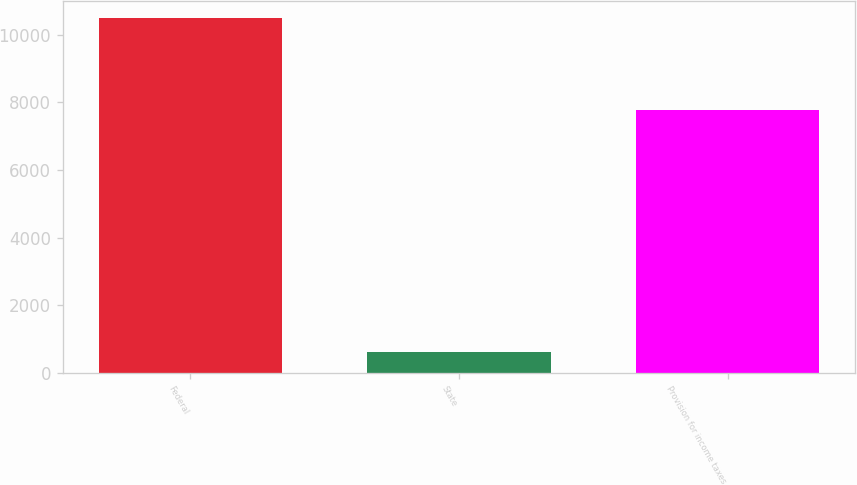<chart> <loc_0><loc_0><loc_500><loc_500><bar_chart><fcel>Federal<fcel>State<fcel>Provision for income taxes<nl><fcel>10485<fcel>630<fcel>7774<nl></chart> 